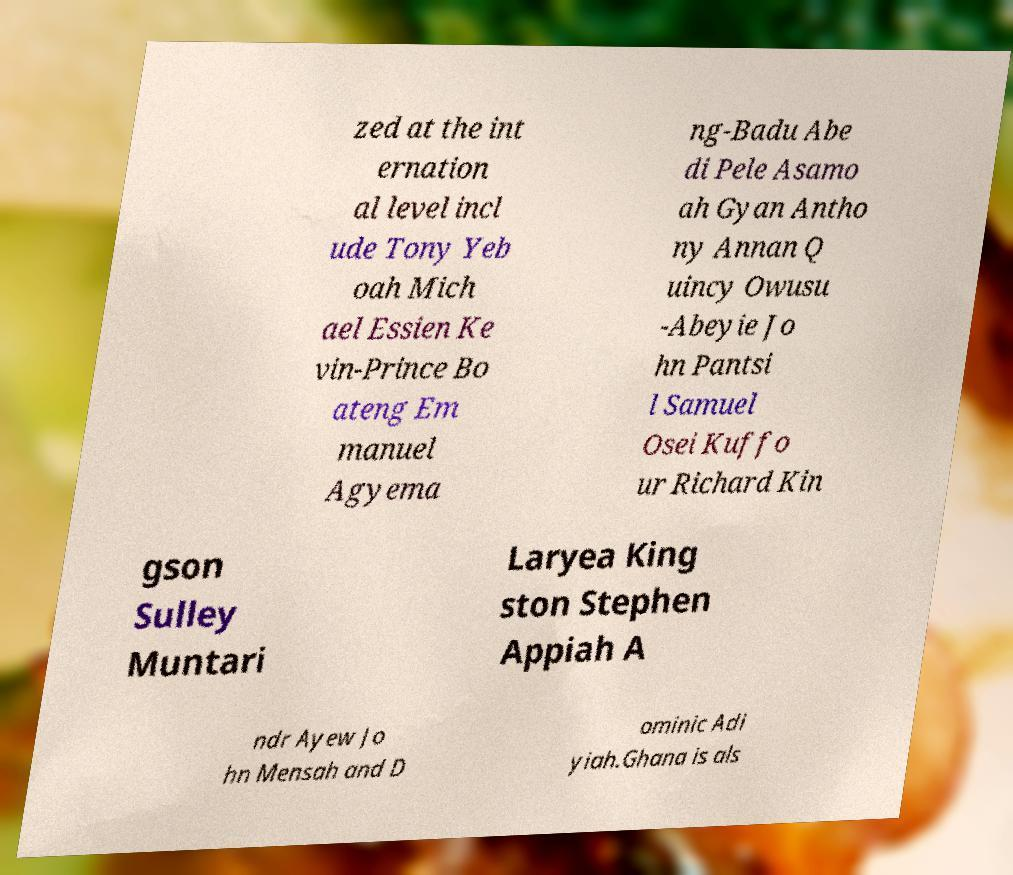There's text embedded in this image that I need extracted. Can you transcribe it verbatim? zed at the int ernation al level incl ude Tony Yeb oah Mich ael Essien Ke vin-Prince Bo ateng Em manuel Agyema ng-Badu Abe di Pele Asamo ah Gyan Antho ny Annan Q uincy Owusu -Abeyie Jo hn Pantsi l Samuel Osei Kuffo ur Richard Kin gson Sulley Muntari Laryea King ston Stephen Appiah A ndr Ayew Jo hn Mensah and D ominic Adi yiah.Ghana is als 